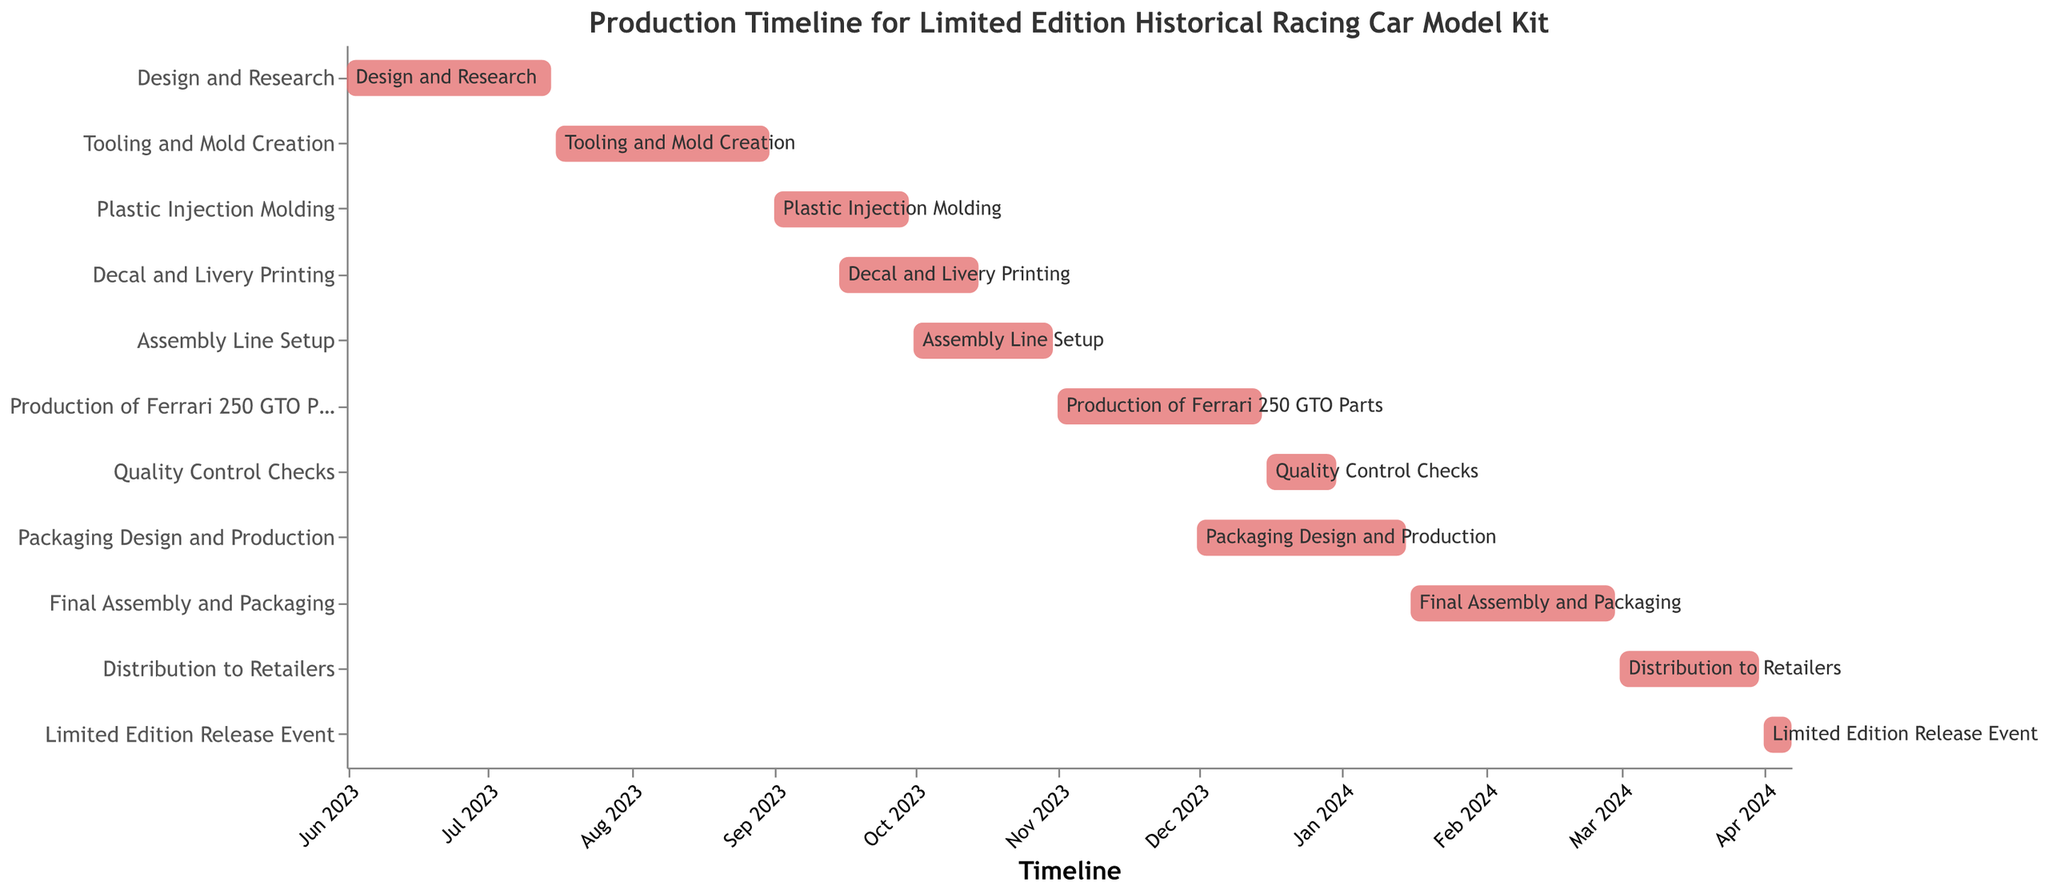Which task starts first? The task that starts first is the one with the earliest start date. Looking at the chart, 'Design and Research' starts on June 1, 2023.
Answer: Design and Research How long does the 'Tooling and Mold Creation' stage last? To find the duration, calculate the difference between the end date and start date for 'Tooling and Mold Creation'. It starts on July 16, 2023, and ends on August 31, 2023.
Answer: 47 days What are the overlapping tasks in September 2023? Overlapping tasks are identified by their timelines intersecting the same periods. In September 2023, 'Plastic Injection Molding' and 'Decal and Livery Printing' overlap.
Answer: Plastic Injection Molding and Decal and Livery Printing Which task immediately follows 'Assembly Line Setup'? The task that starts right after 'Assembly Line Setup' ends is 'Production of Ferrari 250 GTO Parts'. 'Assembly Line Setup' ends on October 31, 2023, and 'Production of Ferrari 250 GTO Parts' starts on November 1, 2023.
Answer: Production of Ferrari 250 GTO Parts Which task has the shortest duration, and how many days does it last? To determine the shortest task, compare the durations of all tasks. 'Limited Edition Release Event' lasts from April 1, 2024, to April 7, 2024, which is 7 days.
Answer: Limited Edition Release Event, 7 days What is the total duration from the start of 'Design and Research' to the end of 'Distribution to Retailers'? Calculate the total duration by finding the difference between the start date of 'Design and Research' (June 1, 2023) and the end date of 'Distribution to Retailers' (March 31, 2024).
Answer: 305 days How many tasks are completed by the end of December 2023? Identify the tasks with end dates on or before December 31, 2023. There are five tasks: 'Design and Research', 'Tooling and Mold Creation', 'Plastic Injection Molding', 'Decal and Livery Printing', and 'Production of Ferrari 250 GTO Parts'.
Answer: 5 tasks Which task is carried out throughout February 2024? The task that includes the entire duration of February 2024 within its timeline is 'Final Assembly and Packaging', which lasts from January 16, 2024, to February 29, 2024.
Answer: Final Assembly and Packaging What is the total duration of 'Production of Ferrari 250 GTO Parts' and 'Quality Control Checks' combined? Calculate the individual durations and sum them. 'Production of Ferrari 250 GTO Parts' lasts from November 1, 2023, to December 15, 2023 (45 days), and 'Quality Control Checks' lasts from December 16, 2023, to December 31, 2023 (16 days). The total is 45 + 16 = 61 days.
Answer: 61 days 